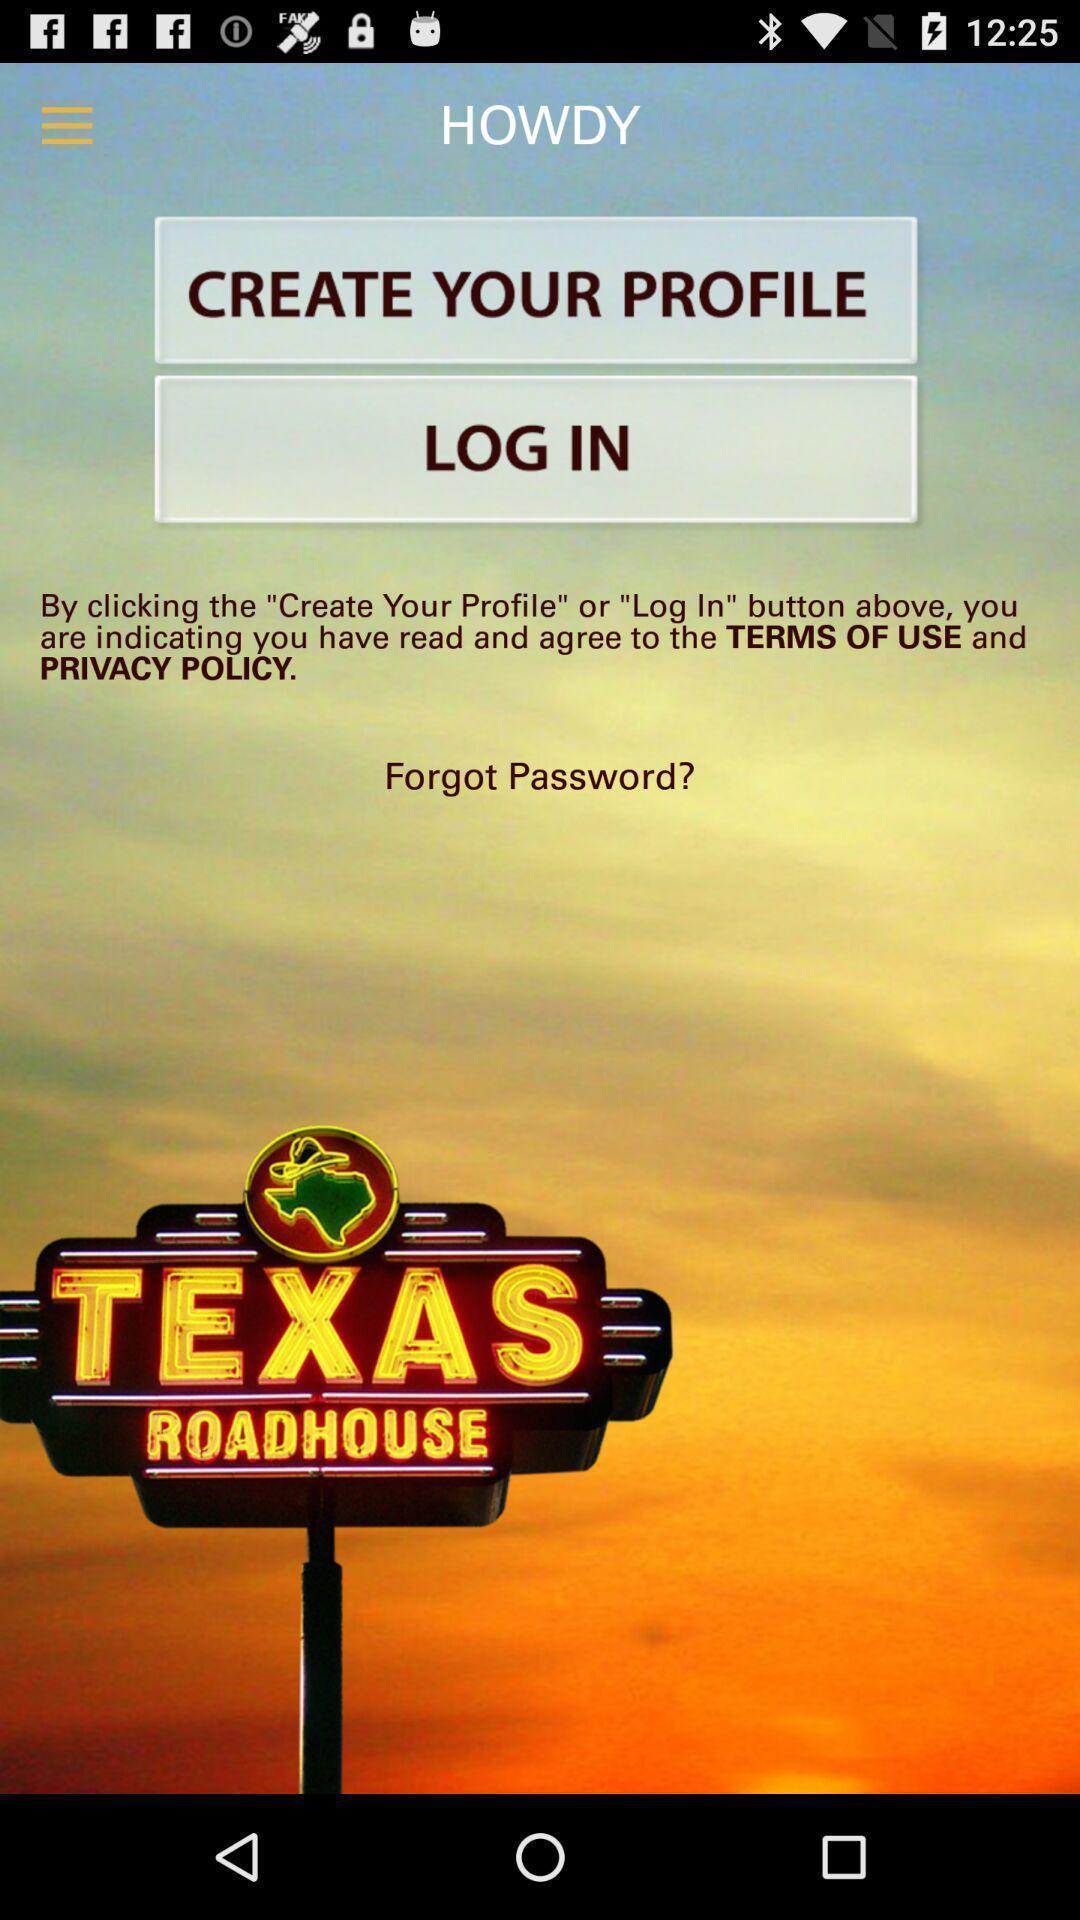Describe the visual elements of this screenshot. Welcome page for a food app. 